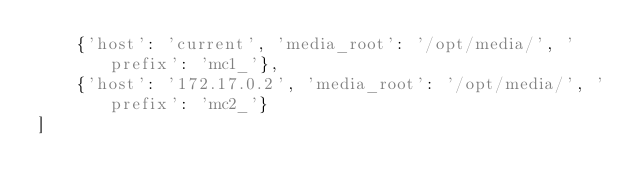<code> <loc_0><loc_0><loc_500><loc_500><_Python_>    {'host': 'current', 'media_root': '/opt/media/', 'prefix': 'mc1_'},
    {'host': '172.17.0.2', 'media_root': '/opt/media/', 'prefix': 'mc2_'}
]</code> 